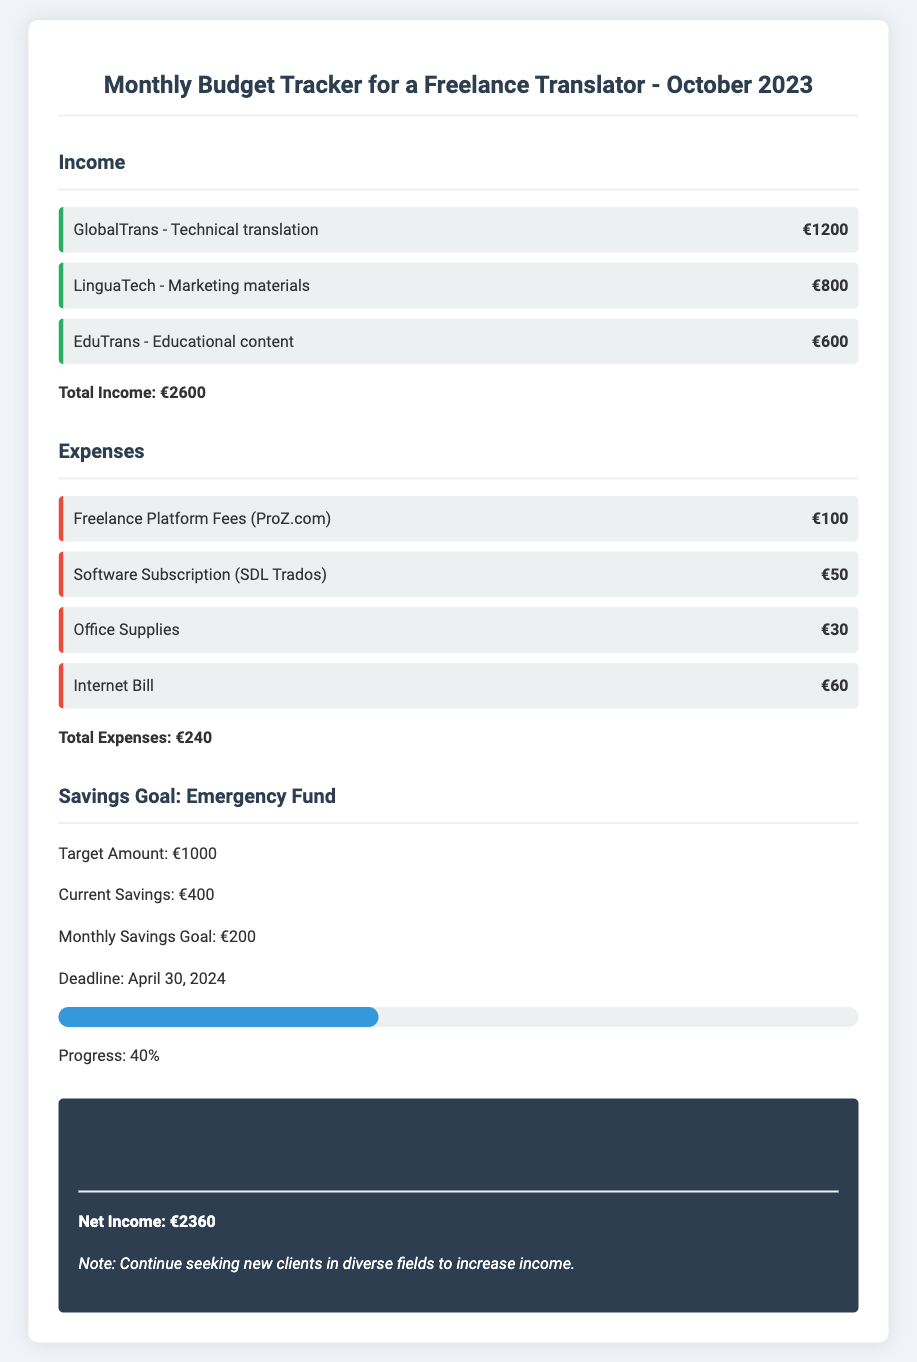What is the total income? The total income is calculated by adding all the income sources listed in the document: €1200 + €800 + €600 = €2600.
Answer: €2600 What is the total amount of expenses? The total expenses are obtained by summing all the listed expenses: €100 + €50 + €30 + €60 = €240.
Answer: €240 What is the current savings amount? The current savings amount is stated as the savings accumulated towards the emergency fund, which is €400.
Answer: €400 What is the monthly savings goal? The monthly savings goal is explicitly mentioned in the document, which is €200.
Answer: €200 What is the net income? The net income is the income minus expenses: €2600 - €240 = €2360.
Answer: €2360 What is the target amount for the emergency fund? The target amount for the emergency fund is specified in the document as €1000.
Answer: €1000 How much progress has been made towards the savings goal? The progress towards the savings goal is indicated as 40%.
Answer: 40% What deadline is set for the savings goal? The deadline for reaching the savings goal is stated as April 30, 2024.
Answer: April 30, 2024 Who is the client for technical translation? The client for technical translation is mentioned as GlobalTrans.
Answer: GlobalTrans What is notable for increasing income? The document notes to continue seeking new clients in diverse fields to increase income.
Answer: Seek new clients in diverse fields 